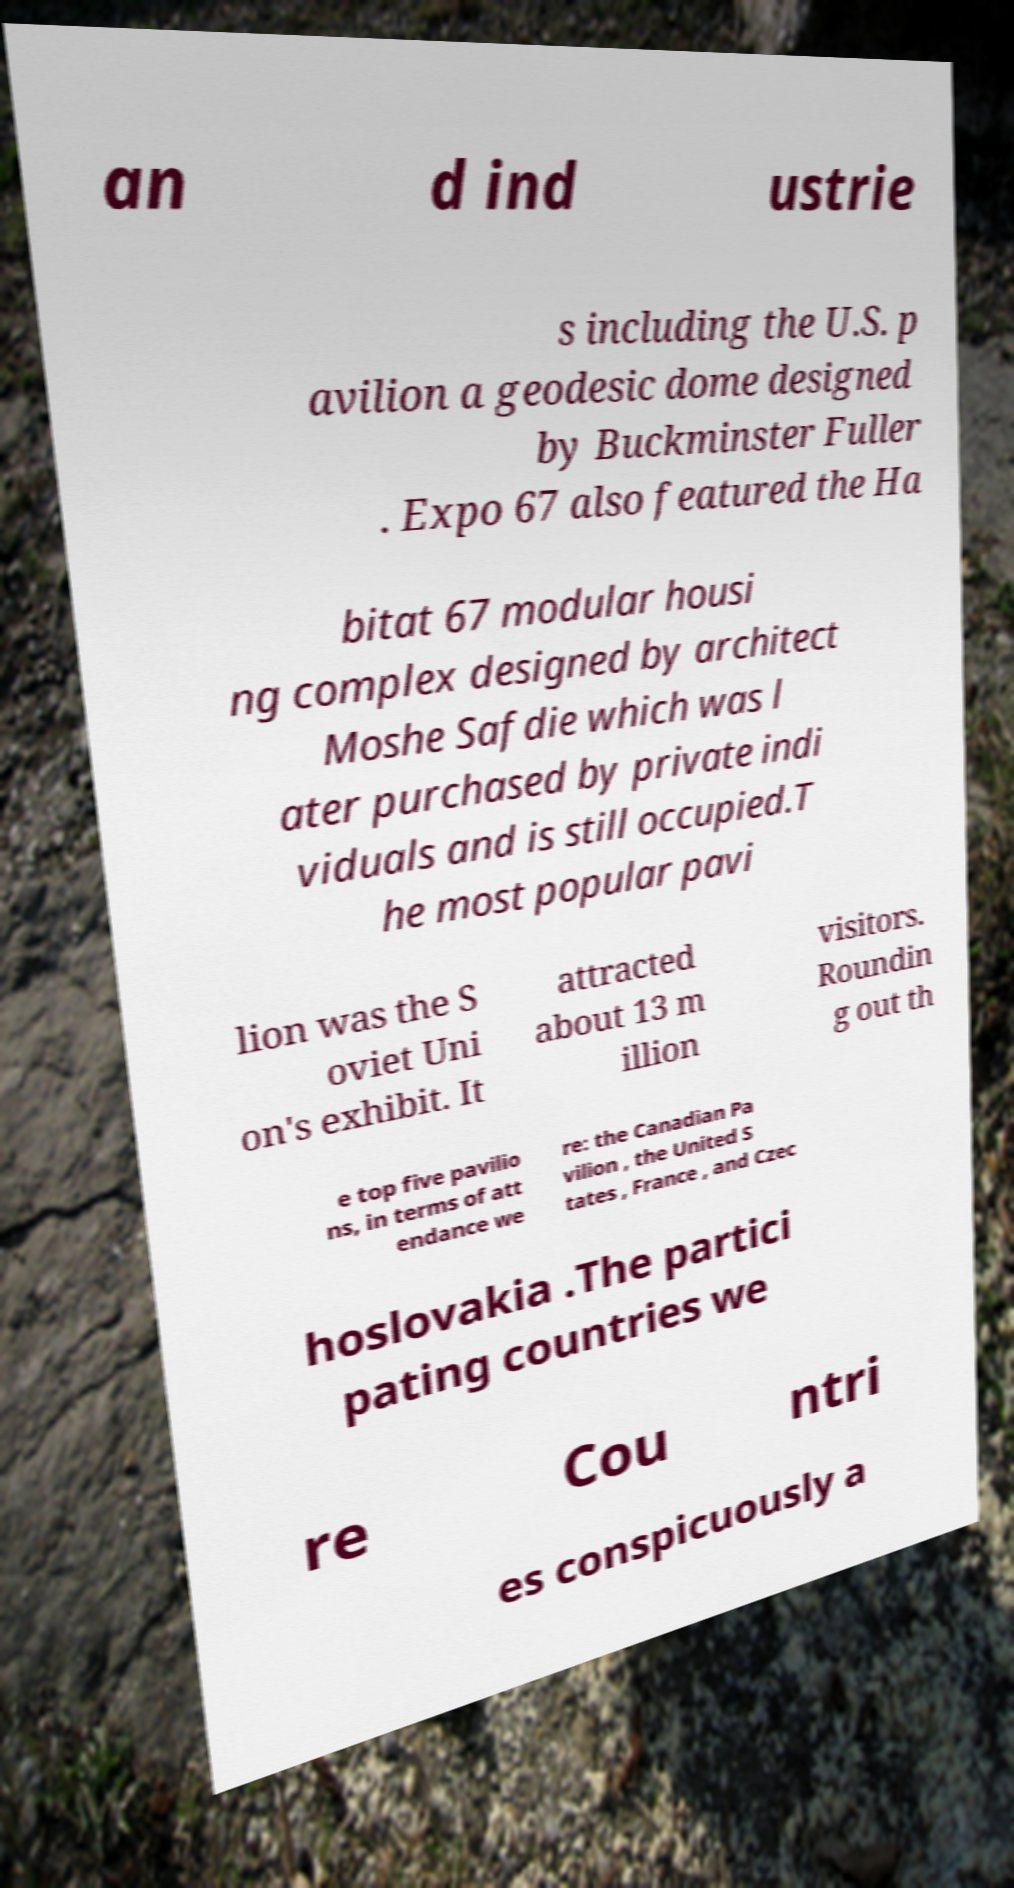Please identify and transcribe the text found in this image. an d ind ustrie s including the U.S. p avilion a geodesic dome designed by Buckminster Fuller . Expo 67 also featured the Ha bitat 67 modular housi ng complex designed by architect Moshe Safdie which was l ater purchased by private indi viduals and is still occupied.T he most popular pavi lion was the S oviet Uni on's exhibit. It attracted about 13 m illion visitors. Roundin g out th e top five pavilio ns, in terms of att endance we re: the Canadian Pa vilion , the United S tates , France , and Czec hoslovakia .The partici pating countries we re Cou ntri es conspicuously a 